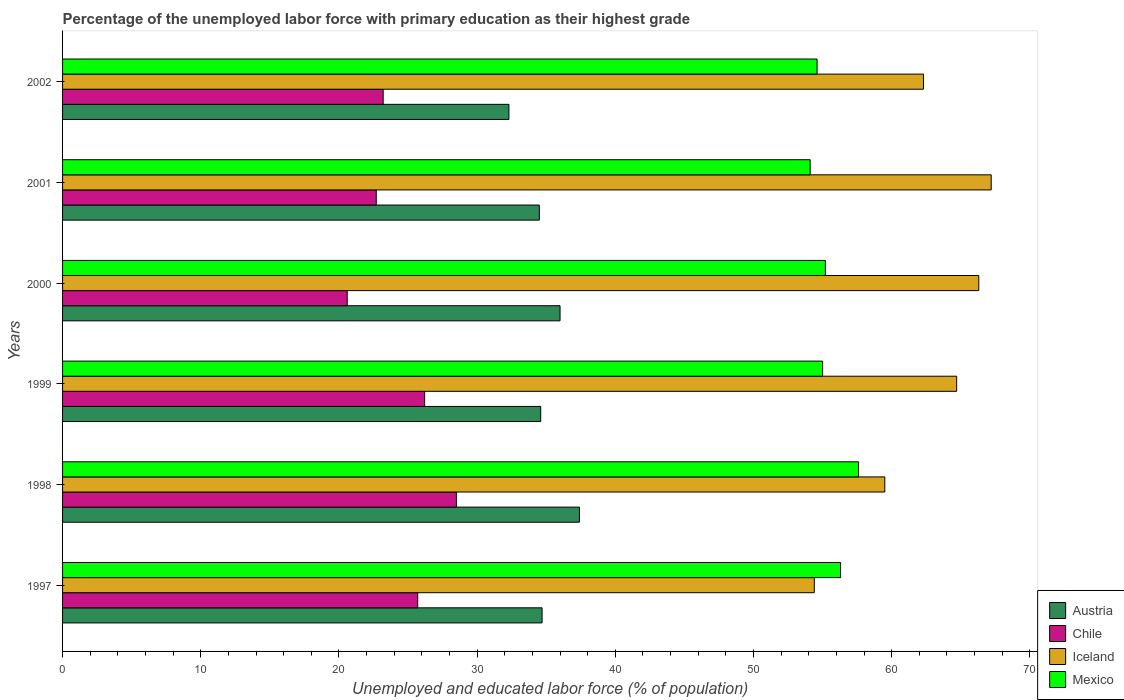How many different coloured bars are there?
Your answer should be compact. 4. How many groups of bars are there?
Offer a very short reply. 6. Are the number of bars on each tick of the Y-axis equal?
Your response must be concise. Yes. How many bars are there on the 3rd tick from the bottom?
Give a very brief answer. 4. What is the percentage of the unemployed labor force with primary education in Iceland in 1998?
Keep it short and to the point. 59.5. Across all years, what is the maximum percentage of the unemployed labor force with primary education in Austria?
Your response must be concise. 37.4. Across all years, what is the minimum percentage of the unemployed labor force with primary education in Austria?
Offer a terse response. 32.3. In which year was the percentage of the unemployed labor force with primary education in Austria maximum?
Provide a short and direct response. 1998. What is the total percentage of the unemployed labor force with primary education in Chile in the graph?
Your answer should be compact. 146.9. What is the difference between the percentage of the unemployed labor force with primary education in Chile in 1998 and that in 1999?
Provide a short and direct response. 2.3. What is the average percentage of the unemployed labor force with primary education in Iceland per year?
Offer a terse response. 62.4. In the year 1999, what is the difference between the percentage of the unemployed labor force with primary education in Chile and percentage of the unemployed labor force with primary education in Mexico?
Your answer should be compact. -28.8. In how many years, is the percentage of the unemployed labor force with primary education in Mexico greater than 22 %?
Keep it short and to the point. 6. What is the ratio of the percentage of the unemployed labor force with primary education in Chile in 2000 to that in 2002?
Keep it short and to the point. 0.89. Is the percentage of the unemployed labor force with primary education in Austria in 1998 less than that in 1999?
Keep it short and to the point. No. Is the difference between the percentage of the unemployed labor force with primary education in Chile in 1998 and 2002 greater than the difference between the percentage of the unemployed labor force with primary education in Mexico in 1998 and 2002?
Offer a very short reply. Yes. What is the difference between the highest and the second highest percentage of the unemployed labor force with primary education in Iceland?
Your answer should be very brief. 0.9. Is it the case that in every year, the sum of the percentage of the unemployed labor force with primary education in Austria and percentage of the unemployed labor force with primary education in Iceland is greater than the sum of percentage of the unemployed labor force with primary education in Mexico and percentage of the unemployed labor force with primary education in Chile?
Your answer should be compact. No. Does the graph contain any zero values?
Your response must be concise. No. Does the graph contain grids?
Make the answer very short. No. Where does the legend appear in the graph?
Give a very brief answer. Bottom right. How are the legend labels stacked?
Keep it short and to the point. Vertical. What is the title of the graph?
Provide a succinct answer. Percentage of the unemployed labor force with primary education as their highest grade. Does "High income: nonOECD" appear as one of the legend labels in the graph?
Give a very brief answer. No. What is the label or title of the X-axis?
Provide a short and direct response. Unemployed and educated labor force (% of population). What is the Unemployed and educated labor force (% of population) in Austria in 1997?
Your answer should be compact. 34.7. What is the Unemployed and educated labor force (% of population) of Chile in 1997?
Your response must be concise. 25.7. What is the Unemployed and educated labor force (% of population) of Iceland in 1997?
Your answer should be compact. 54.4. What is the Unemployed and educated labor force (% of population) of Mexico in 1997?
Make the answer very short. 56.3. What is the Unemployed and educated labor force (% of population) of Austria in 1998?
Offer a terse response. 37.4. What is the Unemployed and educated labor force (% of population) of Iceland in 1998?
Your response must be concise. 59.5. What is the Unemployed and educated labor force (% of population) of Mexico in 1998?
Give a very brief answer. 57.6. What is the Unemployed and educated labor force (% of population) of Austria in 1999?
Offer a very short reply. 34.6. What is the Unemployed and educated labor force (% of population) of Chile in 1999?
Ensure brevity in your answer.  26.2. What is the Unemployed and educated labor force (% of population) in Iceland in 1999?
Offer a terse response. 64.7. What is the Unemployed and educated labor force (% of population) in Austria in 2000?
Ensure brevity in your answer.  36. What is the Unemployed and educated labor force (% of population) of Chile in 2000?
Provide a short and direct response. 20.6. What is the Unemployed and educated labor force (% of population) of Iceland in 2000?
Provide a succinct answer. 66.3. What is the Unemployed and educated labor force (% of population) of Mexico in 2000?
Your answer should be very brief. 55.2. What is the Unemployed and educated labor force (% of population) in Austria in 2001?
Offer a terse response. 34.5. What is the Unemployed and educated labor force (% of population) in Chile in 2001?
Provide a short and direct response. 22.7. What is the Unemployed and educated labor force (% of population) of Iceland in 2001?
Your answer should be compact. 67.2. What is the Unemployed and educated labor force (% of population) of Mexico in 2001?
Offer a very short reply. 54.1. What is the Unemployed and educated labor force (% of population) of Austria in 2002?
Provide a succinct answer. 32.3. What is the Unemployed and educated labor force (% of population) in Chile in 2002?
Give a very brief answer. 23.2. What is the Unemployed and educated labor force (% of population) of Iceland in 2002?
Keep it short and to the point. 62.3. What is the Unemployed and educated labor force (% of population) of Mexico in 2002?
Offer a terse response. 54.6. Across all years, what is the maximum Unemployed and educated labor force (% of population) of Austria?
Keep it short and to the point. 37.4. Across all years, what is the maximum Unemployed and educated labor force (% of population) in Iceland?
Your response must be concise. 67.2. Across all years, what is the maximum Unemployed and educated labor force (% of population) of Mexico?
Make the answer very short. 57.6. Across all years, what is the minimum Unemployed and educated labor force (% of population) in Austria?
Your answer should be very brief. 32.3. Across all years, what is the minimum Unemployed and educated labor force (% of population) in Chile?
Ensure brevity in your answer.  20.6. Across all years, what is the minimum Unemployed and educated labor force (% of population) of Iceland?
Offer a very short reply. 54.4. Across all years, what is the minimum Unemployed and educated labor force (% of population) of Mexico?
Your answer should be very brief. 54.1. What is the total Unemployed and educated labor force (% of population) in Austria in the graph?
Your answer should be compact. 209.5. What is the total Unemployed and educated labor force (% of population) in Chile in the graph?
Give a very brief answer. 146.9. What is the total Unemployed and educated labor force (% of population) in Iceland in the graph?
Give a very brief answer. 374.4. What is the total Unemployed and educated labor force (% of population) in Mexico in the graph?
Your response must be concise. 332.8. What is the difference between the Unemployed and educated labor force (% of population) of Austria in 1997 and that in 1998?
Your answer should be very brief. -2.7. What is the difference between the Unemployed and educated labor force (% of population) in Austria in 1997 and that in 1999?
Your answer should be compact. 0.1. What is the difference between the Unemployed and educated labor force (% of population) in Iceland in 1997 and that in 1999?
Provide a succinct answer. -10.3. What is the difference between the Unemployed and educated labor force (% of population) in Mexico in 1997 and that in 1999?
Your response must be concise. 1.3. What is the difference between the Unemployed and educated labor force (% of population) in Austria in 1997 and that in 2000?
Make the answer very short. -1.3. What is the difference between the Unemployed and educated labor force (% of population) in Chile in 1997 and that in 2000?
Your answer should be compact. 5.1. What is the difference between the Unemployed and educated labor force (% of population) of Chile in 1997 and that in 2001?
Your answer should be compact. 3. What is the difference between the Unemployed and educated labor force (% of population) of Mexico in 1997 and that in 2001?
Your answer should be compact. 2.2. What is the difference between the Unemployed and educated labor force (% of population) in Chile in 1997 and that in 2002?
Offer a terse response. 2.5. What is the difference between the Unemployed and educated labor force (% of population) of Chile in 1998 and that in 1999?
Your answer should be very brief. 2.3. What is the difference between the Unemployed and educated labor force (% of population) of Mexico in 1998 and that in 1999?
Provide a succinct answer. 2.6. What is the difference between the Unemployed and educated labor force (% of population) of Austria in 1998 and that in 2000?
Give a very brief answer. 1.4. What is the difference between the Unemployed and educated labor force (% of population) of Mexico in 1998 and that in 2000?
Your answer should be very brief. 2.4. What is the difference between the Unemployed and educated labor force (% of population) of Mexico in 1998 and that in 2001?
Your response must be concise. 3.5. What is the difference between the Unemployed and educated labor force (% of population) of Austria in 1998 and that in 2002?
Make the answer very short. 5.1. What is the difference between the Unemployed and educated labor force (% of population) in Chile in 1998 and that in 2002?
Provide a succinct answer. 5.3. What is the difference between the Unemployed and educated labor force (% of population) of Iceland in 1998 and that in 2002?
Offer a terse response. -2.8. What is the difference between the Unemployed and educated labor force (% of population) in Mexico in 1998 and that in 2002?
Make the answer very short. 3. What is the difference between the Unemployed and educated labor force (% of population) in Iceland in 1999 and that in 2000?
Your response must be concise. -1.6. What is the difference between the Unemployed and educated labor force (% of population) of Chile in 1999 and that in 2001?
Your answer should be very brief. 3.5. What is the difference between the Unemployed and educated labor force (% of population) in Mexico in 1999 and that in 2001?
Make the answer very short. 0.9. What is the difference between the Unemployed and educated labor force (% of population) in Iceland in 1999 and that in 2002?
Your answer should be compact. 2.4. What is the difference between the Unemployed and educated labor force (% of population) in Chile in 2000 and that in 2001?
Provide a succinct answer. -2.1. What is the difference between the Unemployed and educated labor force (% of population) of Mexico in 2000 and that in 2001?
Offer a terse response. 1.1. What is the difference between the Unemployed and educated labor force (% of population) in Austria in 2000 and that in 2002?
Your answer should be very brief. 3.7. What is the difference between the Unemployed and educated labor force (% of population) in Chile in 2000 and that in 2002?
Provide a succinct answer. -2.6. What is the difference between the Unemployed and educated labor force (% of population) in Mexico in 2000 and that in 2002?
Provide a short and direct response. 0.6. What is the difference between the Unemployed and educated labor force (% of population) in Iceland in 2001 and that in 2002?
Ensure brevity in your answer.  4.9. What is the difference between the Unemployed and educated labor force (% of population) in Mexico in 2001 and that in 2002?
Your answer should be compact. -0.5. What is the difference between the Unemployed and educated labor force (% of population) in Austria in 1997 and the Unemployed and educated labor force (% of population) in Chile in 1998?
Your answer should be compact. 6.2. What is the difference between the Unemployed and educated labor force (% of population) of Austria in 1997 and the Unemployed and educated labor force (% of population) of Iceland in 1998?
Ensure brevity in your answer.  -24.8. What is the difference between the Unemployed and educated labor force (% of population) in Austria in 1997 and the Unemployed and educated labor force (% of population) in Mexico in 1998?
Give a very brief answer. -22.9. What is the difference between the Unemployed and educated labor force (% of population) in Chile in 1997 and the Unemployed and educated labor force (% of population) in Iceland in 1998?
Your answer should be very brief. -33.8. What is the difference between the Unemployed and educated labor force (% of population) in Chile in 1997 and the Unemployed and educated labor force (% of population) in Mexico in 1998?
Ensure brevity in your answer.  -31.9. What is the difference between the Unemployed and educated labor force (% of population) of Austria in 1997 and the Unemployed and educated labor force (% of population) of Chile in 1999?
Your answer should be compact. 8.5. What is the difference between the Unemployed and educated labor force (% of population) of Austria in 1997 and the Unemployed and educated labor force (% of population) of Mexico in 1999?
Offer a terse response. -20.3. What is the difference between the Unemployed and educated labor force (% of population) in Chile in 1997 and the Unemployed and educated labor force (% of population) in Iceland in 1999?
Ensure brevity in your answer.  -39. What is the difference between the Unemployed and educated labor force (% of population) in Chile in 1997 and the Unemployed and educated labor force (% of population) in Mexico in 1999?
Provide a short and direct response. -29.3. What is the difference between the Unemployed and educated labor force (% of population) of Austria in 1997 and the Unemployed and educated labor force (% of population) of Chile in 2000?
Give a very brief answer. 14.1. What is the difference between the Unemployed and educated labor force (% of population) of Austria in 1997 and the Unemployed and educated labor force (% of population) of Iceland in 2000?
Your response must be concise. -31.6. What is the difference between the Unemployed and educated labor force (% of population) of Austria in 1997 and the Unemployed and educated labor force (% of population) of Mexico in 2000?
Give a very brief answer. -20.5. What is the difference between the Unemployed and educated labor force (% of population) of Chile in 1997 and the Unemployed and educated labor force (% of population) of Iceland in 2000?
Your answer should be compact. -40.6. What is the difference between the Unemployed and educated labor force (% of population) in Chile in 1997 and the Unemployed and educated labor force (% of population) in Mexico in 2000?
Provide a succinct answer. -29.5. What is the difference between the Unemployed and educated labor force (% of population) in Iceland in 1997 and the Unemployed and educated labor force (% of population) in Mexico in 2000?
Offer a terse response. -0.8. What is the difference between the Unemployed and educated labor force (% of population) in Austria in 1997 and the Unemployed and educated labor force (% of population) in Chile in 2001?
Give a very brief answer. 12. What is the difference between the Unemployed and educated labor force (% of population) of Austria in 1997 and the Unemployed and educated labor force (% of population) of Iceland in 2001?
Make the answer very short. -32.5. What is the difference between the Unemployed and educated labor force (% of population) of Austria in 1997 and the Unemployed and educated labor force (% of population) of Mexico in 2001?
Offer a terse response. -19.4. What is the difference between the Unemployed and educated labor force (% of population) in Chile in 1997 and the Unemployed and educated labor force (% of population) in Iceland in 2001?
Ensure brevity in your answer.  -41.5. What is the difference between the Unemployed and educated labor force (% of population) in Chile in 1997 and the Unemployed and educated labor force (% of population) in Mexico in 2001?
Your answer should be very brief. -28.4. What is the difference between the Unemployed and educated labor force (% of population) in Austria in 1997 and the Unemployed and educated labor force (% of population) in Chile in 2002?
Provide a short and direct response. 11.5. What is the difference between the Unemployed and educated labor force (% of population) in Austria in 1997 and the Unemployed and educated labor force (% of population) in Iceland in 2002?
Your answer should be compact. -27.6. What is the difference between the Unemployed and educated labor force (% of population) in Austria in 1997 and the Unemployed and educated labor force (% of population) in Mexico in 2002?
Offer a terse response. -19.9. What is the difference between the Unemployed and educated labor force (% of population) in Chile in 1997 and the Unemployed and educated labor force (% of population) in Iceland in 2002?
Your answer should be compact. -36.6. What is the difference between the Unemployed and educated labor force (% of population) of Chile in 1997 and the Unemployed and educated labor force (% of population) of Mexico in 2002?
Keep it short and to the point. -28.9. What is the difference between the Unemployed and educated labor force (% of population) of Iceland in 1997 and the Unemployed and educated labor force (% of population) of Mexico in 2002?
Provide a short and direct response. -0.2. What is the difference between the Unemployed and educated labor force (% of population) of Austria in 1998 and the Unemployed and educated labor force (% of population) of Iceland in 1999?
Your answer should be very brief. -27.3. What is the difference between the Unemployed and educated labor force (% of population) of Austria in 1998 and the Unemployed and educated labor force (% of population) of Mexico in 1999?
Offer a very short reply. -17.6. What is the difference between the Unemployed and educated labor force (% of population) of Chile in 1998 and the Unemployed and educated labor force (% of population) of Iceland in 1999?
Offer a terse response. -36.2. What is the difference between the Unemployed and educated labor force (% of population) of Chile in 1998 and the Unemployed and educated labor force (% of population) of Mexico in 1999?
Give a very brief answer. -26.5. What is the difference between the Unemployed and educated labor force (% of population) in Iceland in 1998 and the Unemployed and educated labor force (% of population) in Mexico in 1999?
Your answer should be compact. 4.5. What is the difference between the Unemployed and educated labor force (% of population) of Austria in 1998 and the Unemployed and educated labor force (% of population) of Iceland in 2000?
Keep it short and to the point. -28.9. What is the difference between the Unemployed and educated labor force (% of population) of Austria in 1998 and the Unemployed and educated labor force (% of population) of Mexico in 2000?
Give a very brief answer. -17.8. What is the difference between the Unemployed and educated labor force (% of population) of Chile in 1998 and the Unemployed and educated labor force (% of population) of Iceland in 2000?
Your response must be concise. -37.8. What is the difference between the Unemployed and educated labor force (% of population) in Chile in 1998 and the Unemployed and educated labor force (% of population) in Mexico in 2000?
Provide a short and direct response. -26.7. What is the difference between the Unemployed and educated labor force (% of population) in Iceland in 1998 and the Unemployed and educated labor force (% of population) in Mexico in 2000?
Offer a terse response. 4.3. What is the difference between the Unemployed and educated labor force (% of population) of Austria in 1998 and the Unemployed and educated labor force (% of population) of Chile in 2001?
Keep it short and to the point. 14.7. What is the difference between the Unemployed and educated labor force (% of population) of Austria in 1998 and the Unemployed and educated labor force (% of population) of Iceland in 2001?
Provide a succinct answer. -29.8. What is the difference between the Unemployed and educated labor force (% of population) of Austria in 1998 and the Unemployed and educated labor force (% of population) of Mexico in 2001?
Give a very brief answer. -16.7. What is the difference between the Unemployed and educated labor force (% of population) of Chile in 1998 and the Unemployed and educated labor force (% of population) of Iceland in 2001?
Offer a terse response. -38.7. What is the difference between the Unemployed and educated labor force (% of population) in Chile in 1998 and the Unemployed and educated labor force (% of population) in Mexico in 2001?
Provide a succinct answer. -25.6. What is the difference between the Unemployed and educated labor force (% of population) in Iceland in 1998 and the Unemployed and educated labor force (% of population) in Mexico in 2001?
Make the answer very short. 5.4. What is the difference between the Unemployed and educated labor force (% of population) in Austria in 1998 and the Unemployed and educated labor force (% of population) in Iceland in 2002?
Your answer should be compact. -24.9. What is the difference between the Unemployed and educated labor force (% of population) in Austria in 1998 and the Unemployed and educated labor force (% of population) in Mexico in 2002?
Offer a terse response. -17.2. What is the difference between the Unemployed and educated labor force (% of population) in Chile in 1998 and the Unemployed and educated labor force (% of population) in Iceland in 2002?
Your answer should be very brief. -33.8. What is the difference between the Unemployed and educated labor force (% of population) of Chile in 1998 and the Unemployed and educated labor force (% of population) of Mexico in 2002?
Offer a terse response. -26.1. What is the difference between the Unemployed and educated labor force (% of population) of Austria in 1999 and the Unemployed and educated labor force (% of population) of Iceland in 2000?
Provide a short and direct response. -31.7. What is the difference between the Unemployed and educated labor force (% of population) in Austria in 1999 and the Unemployed and educated labor force (% of population) in Mexico in 2000?
Your response must be concise. -20.6. What is the difference between the Unemployed and educated labor force (% of population) in Chile in 1999 and the Unemployed and educated labor force (% of population) in Iceland in 2000?
Ensure brevity in your answer.  -40.1. What is the difference between the Unemployed and educated labor force (% of population) of Chile in 1999 and the Unemployed and educated labor force (% of population) of Mexico in 2000?
Offer a terse response. -29. What is the difference between the Unemployed and educated labor force (% of population) in Iceland in 1999 and the Unemployed and educated labor force (% of population) in Mexico in 2000?
Your answer should be compact. 9.5. What is the difference between the Unemployed and educated labor force (% of population) of Austria in 1999 and the Unemployed and educated labor force (% of population) of Iceland in 2001?
Provide a succinct answer. -32.6. What is the difference between the Unemployed and educated labor force (% of population) in Austria in 1999 and the Unemployed and educated labor force (% of population) in Mexico in 2001?
Offer a terse response. -19.5. What is the difference between the Unemployed and educated labor force (% of population) of Chile in 1999 and the Unemployed and educated labor force (% of population) of Iceland in 2001?
Make the answer very short. -41. What is the difference between the Unemployed and educated labor force (% of population) of Chile in 1999 and the Unemployed and educated labor force (% of population) of Mexico in 2001?
Your answer should be very brief. -27.9. What is the difference between the Unemployed and educated labor force (% of population) in Austria in 1999 and the Unemployed and educated labor force (% of population) in Chile in 2002?
Provide a short and direct response. 11.4. What is the difference between the Unemployed and educated labor force (% of population) in Austria in 1999 and the Unemployed and educated labor force (% of population) in Iceland in 2002?
Provide a succinct answer. -27.7. What is the difference between the Unemployed and educated labor force (% of population) of Austria in 1999 and the Unemployed and educated labor force (% of population) of Mexico in 2002?
Your response must be concise. -20. What is the difference between the Unemployed and educated labor force (% of population) in Chile in 1999 and the Unemployed and educated labor force (% of population) in Iceland in 2002?
Your answer should be compact. -36.1. What is the difference between the Unemployed and educated labor force (% of population) in Chile in 1999 and the Unemployed and educated labor force (% of population) in Mexico in 2002?
Your answer should be very brief. -28.4. What is the difference between the Unemployed and educated labor force (% of population) of Austria in 2000 and the Unemployed and educated labor force (% of population) of Iceland in 2001?
Provide a succinct answer. -31.2. What is the difference between the Unemployed and educated labor force (% of population) of Austria in 2000 and the Unemployed and educated labor force (% of population) of Mexico in 2001?
Make the answer very short. -18.1. What is the difference between the Unemployed and educated labor force (% of population) of Chile in 2000 and the Unemployed and educated labor force (% of population) of Iceland in 2001?
Offer a very short reply. -46.6. What is the difference between the Unemployed and educated labor force (% of population) of Chile in 2000 and the Unemployed and educated labor force (% of population) of Mexico in 2001?
Offer a very short reply. -33.5. What is the difference between the Unemployed and educated labor force (% of population) of Austria in 2000 and the Unemployed and educated labor force (% of population) of Iceland in 2002?
Provide a succinct answer. -26.3. What is the difference between the Unemployed and educated labor force (% of population) of Austria in 2000 and the Unemployed and educated labor force (% of population) of Mexico in 2002?
Make the answer very short. -18.6. What is the difference between the Unemployed and educated labor force (% of population) in Chile in 2000 and the Unemployed and educated labor force (% of population) in Iceland in 2002?
Ensure brevity in your answer.  -41.7. What is the difference between the Unemployed and educated labor force (% of population) of Chile in 2000 and the Unemployed and educated labor force (% of population) of Mexico in 2002?
Offer a terse response. -34. What is the difference between the Unemployed and educated labor force (% of population) of Iceland in 2000 and the Unemployed and educated labor force (% of population) of Mexico in 2002?
Offer a terse response. 11.7. What is the difference between the Unemployed and educated labor force (% of population) of Austria in 2001 and the Unemployed and educated labor force (% of population) of Iceland in 2002?
Offer a terse response. -27.8. What is the difference between the Unemployed and educated labor force (% of population) of Austria in 2001 and the Unemployed and educated labor force (% of population) of Mexico in 2002?
Your answer should be compact. -20.1. What is the difference between the Unemployed and educated labor force (% of population) of Chile in 2001 and the Unemployed and educated labor force (% of population) of Iceland in 2002?
Provide a short and direct response. -39.6. What is the difference between the Unemployed and educated labor force (% of population) of Chile in 2001 and the Unemployed and educated labor force (% of population) of Mexico in 2002?
Provide a short and direct response. -31.9. What is the average Unemployed and educated labor force (% of population) of Austria per year?
Your answer should be very brief. 34.92. What is the average Unemployed and educated labor force (% of population) in Chile per year?
Keep it short and to the point. 24.48. What is the average Unemployed and educated labor force (% of population) of Iceland per year?
Keep it short and to the point. 62.4. What is the average Unemployed and educated labor force (% of population) of Mexico per year?
Your answer should be compact. 55.47. In the year 1997, what is the difference between the Unemployed and educated labor force (% of population) of Austria and Unemployed and educated labor force (% of population) of Iceland?
Offer a terse response. -19.7. In the year 1997, what is the difference between the Unemployed and educated labor force (% of population) of Austria and Unemployed and educated labor force (% of population) of Mexico?
Ensure brevity in your answer.  -21.6. In the year 1997, what is the difference between the Unemployed and educated labor force (% of population) in Chile and Unemployed and educated labor force (% of population) in Iceland?
Offer a very short reply. -28.7. In the year 1997, what is the difference between the Unemployed and educated labor force (% of population) in Chile and Unemployed and educated labor force (% of population) in Mexico?
Keep it short and to the point. -30.6. In the year 1998, what is the difference between the Unemployed and educated labor force (% of population) of Austria and Unemployed and educated labor force (% of population) of Chile?
Offer a very short reply. 8.9. In the year 1998, what is the difference between the Unemployed and educated labor force (% of population) of Austria and Unemployed and educated labor force (% of population) of Iceland?
Give a very brief answer. -22.1. In the year 1998, what is the difference between the Unemployed and educated labor force (% of population) of Austria and Unemployed and educated labor force (% of population) of Mexico?
Make the answer very short. -20.2. In the year 1998, what is the difference between the Unemployed and educated labor force (% of population) of Chile and Unemployed and educated labor force (% of population) of Iceland?
Ensure brevity in your answer.  -31. In the year 1998, what is the difference between the Unemployed and educated labor force (% of population) of Chile and Unemployed and educated labor force (% of population) of Mexico?
Offer a very short reply. -29.1. In the year 1999, what is the difference between the Unemployed and educated labor force (% of population) in Austria and Unemployed and educated labor force (% of population) in Iceland?
Make the answer very short. -30.1. In the year 1999, what is the difference between the Unemployed and educated labor force (% of population) of Austria and Unemployed and educated labor force (% of population) of Mexico?
Offer a terse response. -20.4. In the year 1999, what is the difference between the Unemployed and educated labor force (% of population) in Chile and Unemployed and educated labor force (% of population) in Iceland?
Ensure brevity in your answer.  -38.5. In the year 1999, what is the difference between the Unemployed and educated labor force (% of population) in Chile and Unemployed and educated labor force (% of population) in Mexico?
Your response must be concise. -28.8. In the year 1999, what is the difference between the Unemployed and educated labor force (% of population) of Iceland and Unemployed and educated labor force (% of population) of Mexico?
Provide a succinct answer. 9.7. In the year 2000, what is the difference between the Unemployed and educated labor force (% of population) in Austria and Unemployed and educated labor force (% of population) in Iceland?
Keep it short and to the point. -30.3. In the year 2000, what is the difference between the Unemployed and educated labor force (% of population) in Austria and Unemployed and educated labor force (% of population) in Mexico?
Ensure brevity in your answer.  -19.2. In the year 2000, what is the difference between the Unemployed and educated labor force (% of population) in Chile and Unemployed and educated labor force (% of population) in Iceland?
Offer a terse response. -45.7. In the year 2000, what is the difference between the Unemployed and educated labor force (% of population) in Chile and Unemployed and educated labor force (% of population) in Mexico?
Your answer should be very brief. -34.6. In the year 2000, what is the difference between the Unemployed and educated labor force (% of population) in Iceland and Unemployed and educated labor force (% of population) in Mexico?
Your answer should be very brief. 11.1. In the year 2001, what is the difference between the Unemployed and educated labor force (% of population) in Austria and Unemployed and educated labor force (% of population) in Chile?
Make the answer very short. 11.8. In the year 2001, what is the difference between the Unemployed and educated labor force (% of population) of Austria and Unemployed and educated labor force (% of population) of Iceland?
Provide a short and direct response. -32.7. In the year 2001, what is the difference between the Unemployed and educated labor force (% of population) of Austria and Unemployed and educated labor force (% of population) of Mexico?
Your answer should be compact. -19.6. In the year 2001, what is the difference between the Unemployed and educated labor force (% of population) of Chile and Unemployed and educated labor force (% of population) of Iceland?
Offer a very short reply. -44.5. In the year 2001, what is the difference between the Unemployed and educated labor force (% of population) of Chile and Unemployed and educated labor force (% of population) of Mexico?
Keep it short and to the point. -31.4. In the year 2001, what is the difference between the Unemployed and educated labor force (% of population) of Iceland and Unemployed and educated labor force (% of population) of Mexico?
Keep it short and to the point. 13.1. In the year 2002, what is the difference between the Unemployed and educated labor force (% of population) in Austria and Unemployed and educated labor force (% of population) in Chile?
Offer a terse response. 9.1. In the year 2002, what is the difference between the Unemployed and educated labor force (% of population) of Austria and Unemployed and educated labor force (% of population) of Iceland?
Provide a short and direct response. -30. In the year 2002, what is the difference between the Unemployed and educated labor force (% of population) in Austria and Unemployed and educated labor force (% of population) in Mexico?
Ensure brevity in your answer.  -22.3. In the year 2002, what is the difference between the Unemployed and educated labor force (% of population) of Chile and Unemployed and educated labor force (% of population) of Iceland?
Your answer should be compact. -39.1. In the year 2002, what is the difference between the Unemployed and educated labor force (% of population) in Chile and Unemployed and educated labor force (% of population) in Mexico?
Offer a terse response. -31.4. In the year 2002, what is the difference between the Unemployed and educated labor force (% of population) of Iceland and Unemployed and educated labor force (% of population) of Mexico?
Give a very brief answer. 7.7. What is the ratio of the Unemployed and educated labor force (% of population) of Austria in 1997 to that in 1998?
Your answer should be compact. 0.93. What is the ratio of the Unemployed and educated labor force (% of population) of Chile in 1997 to that in 1998?
Your response must be concise. 0.9. What is the ratio of the Unemployed and educated labor force (% of population) of Iceland in 1997 to that in 1998?
Offer a terse response. 0.91. What is the ratio of the Unemployed and educated labor force (% of population) of Mexico in 1997 to that in 1998?
Provide a succinct answer. 0.98. What is the ratio of the Unemployed and educated labor force (% of population) in Chile in 1997 to that in 1999?
Provide a short and direct response. 0.98. What is the ratio of the Unemployed and educated labor force (% of population) of Iceland in 1997 to that in 1999?
Offer a very short reply. 0.84. What is the ratio of the Unemployed and educated labor force (% of population) of Mexico in 1997 to that in 1999?
Offer a terse response. 1.02. What is the ratio of the Unemployed and educated labor force (% of population) of Austria in 1997 to that in 2000?
Provide a succinct answer. 0.96. What is the ratio of the Unemployed and educated labor force (% of population) of Chile in 1997 to that in 2000?
Give a very brief answer. 1.25. What is the ratio of the Unemployed and educated labor force (% of population) of Iceland in 1997 to that in 2000?
Keep it short and to the point. 0.82. What is the ratio of the Unemployed and educated labor force (% of population) in Mexico in 1997 to that in 2000?
Keep it short and to the point. 1.02. What is the ratio of the Unemployed and educated labor force (% of population) of Chile in 1997 to that in 2001?
Offer a terse response. 1.13. What is the ratio of the Unemployed and educated labor force (% of population) of Iceland in 1997 to that in 2001?
Your response must be concise. 0.81. What is the ratio of the Unemployed and educated labor force (% of population) in Mexico in 1997 to that in 2001?
Your response must be concise. 1.04. What is the ratio of the Unemployed and educated labor force (% of population) of Austria in 1997 to that in 2002?
Provide a succinct answer. 1.07. What is the ratio of the Unemployed and educated labor force (% of population) in Chile in 1997 to that in 2002?
Make the answer very short. 1.11. What is the ratio of the Unemployed and educated labor force (% of population) of Iceland in 1997 to that in 2002?
Keep it short and to the point. 0.87. What is the ratio of the Unemployed and educated labor force (% of population) of Mexico in 1997 to that in 2002?
Your response must be concise. 1.03. What is the ratio of the Unemployed and educated labor force (% of population) in Austria in 1998 to that in 1999?
Your response must be concise. 1.08. What is the ratio of the Unemployed and educated labor force (% of population) in Chile in 1998 to that in 1999?
Give a very brief answer. 1.09. What is the ratio of the Unemployed and educated labor force (% of population) in Iceland in 1998 to that in 1999?
Make the answer very short. 0.92. What is the ratio of the Unemployed and educated labor force (% of population) of Mexico in 1998 to that in 1999?
Your answer should be very brief. 1.05. What is the ratio of the Unemployed and educated labor force (% of population) of Austria in 1998 to that in 2000?
Keep it short and to the point. 1.04. What is the ratio of the Unemployed and educated labor force (% of population) in Chile in 1998 to that in 2000?
Offer a very short reply. 1.38. What is the ratio of the Unemployed and educated labor force (% of population) in Iceland in 1998 to that in 2000?
Provide a succinct answer. 0.9. What is the ratio of the Unemployed and educated labor force (% of population) in Mexico in 1998 to that in 2000?
Make the answer very short. 1.04. What is the ratio of the Unemployed and educated labor force (% of population) in Austria in 1998 to that in 2001?
Ensure brevity in your answer.  1.08. What is the ratio of the Unemployed and educated labor force (% of population) in Chile in 1998 to that in 2001?
Your answer should be very brief. 1.26. What is the ratio of the Unemployed and educated labor force (% of population) in Iceland in 1998 to that in 2001?
Offer a terse response. 0.89. What is the ratio of the Unemployed and educated labor force (% of population) of Mexico in 1998 to that in 2001?
Offer a terse response. 1.06. What is the ratio of the Unemployed and educated labor force (% of population) in Austria in 1998 to that in 2002?
Offer a terse response. 1.16. What is the ratio of the Unemployed and educated labor force (% of population) in Chile in 1998 to that in 2002?
Ensure brevity in your answer.  1.23. What is the ratio of the Unemployed and educated labor force (% of population) of Iceland in 1998 to that in 2002?
Give a very brief answer. 0.96. What is the ratio of the Unemployed and educated labor force (% of population) of Mexico in 1998 to that in 2002?
Ensure brevity in your answer.  1.05. What is the ratio of the Unemployed and educated labor force (% of population) in Austria in 1999 to that in 2000?
Your answer should be very brief. 0.96. What is the ratio of the Unemployed and educated labor force (% of population) in Chile in 1999 to that in 2000?
Your response must be concise. 1.27. What is the ratio of the Unemployed and educated labor force (% of population) in Iceland in 1999 to that in 2000?
Your answer should be very brief. 0.98. What is the ratio of the Unemployed and educated labor force (% of population) of Austria in 1999 to that in 2001?
Offer a very short reply. 1. What is the ratio of the Unemployed and educated labor force (% of population) of Chile in 1999 to that in 2001?
Your response must be concise. 1.15. What is the ratio of the Unemployed and educated labor force (% of population) of Iceland in 1999 to that in 2001?
Your answer should be compact. 0.96. What is the ratio of the Unemployed and educated labor force (% of population) in Mexico in 1999 to that in 2001?
Keep it short and to the point. 1.02. What is the ratio of the Unemployed and educated labor force (% of population) in Austria in 1999 to that in 2002?
Your answer should be compact. 1.07. What is the ratio of the Unemployed and educated labor force (% of population) in Chile in 1999 to that in 2002?
Provide a short and direct response. 1.13. What is the ratio of the Unemployed and educated labor force (% of population) of Iceland in 1999 to that in 2002?
Give a very brief answer. 1.04. What is the ratio of the Unemployed and educated labor force (% of population) in Mexico in 1999 to that in 2002?
Keep it short and to the point. 1.01. What is the ratio of the Unemployed and educated labor force (% of population) in Austria in 2000 to that in 2001?
Provide a short and direct response. 1.04. What is the ratio of the Unemployed and educated labor force (% of population) in Chile in 2000 to that in 2001?
Provide a short and direct response. 0.91. What is the ratio of the Unemployed and educated labor force (% of population) in Iceland in 2000 to that in 2001?
Make the answer very short. 0.99. What is the ratio of the Unemployed and educated labor force (% of population) of Mexico in 2000 to that in 2001?
Keep it short and to the point. 1.02. What is the ratio of the Unemployed and educated labor force (% of population) in Austria in 2000 to that in 2002?
Provide a succinct answer. 1.11. What is the ratio of the Unemployed and educated labor force (% of population) in Chile in 2000 to that in 2002?
Your response must be concise. 0.89. What is the ratio of the Unemployed and educated labor force (% of population) of Iceland in 2000 to that in 2002?
Provide a succinct answer. 1.06. What is the ratio of the Unemployed and educated labor force (% of population) of Austria in 2001 to that in 2002?
Offer a very short reply. 1.07. What is the ratio of the Unemployed and educated labor force (% of population) in Chile in 2001 to that in 2002?
Offer a terse response. 0.98. What is the ratio of the Unemployed and educated labor force (% of population) of Iceland in 2001 to that in 2002?
Make the answer very short. 1.08. What is the ratio of the Unemployed and educated labor force (% of population) in Mexico in 2001 to that in 2002?
Offer a terse response. 0.99. What is the difference between the highest and the second highest Unemployed and educated labor force (% of population) in Chile?
Provide a succinct answer. 2.3. What is the difference between the highest and the second highest Unemployed and educated labor force (% of population) of Mexico?
Offer a very short reply. 1.3. What is the difference between the highest and the lowest Unemployed and educated labor force (% of population) in Chile?
Provide a short and direct response. 7.9. 